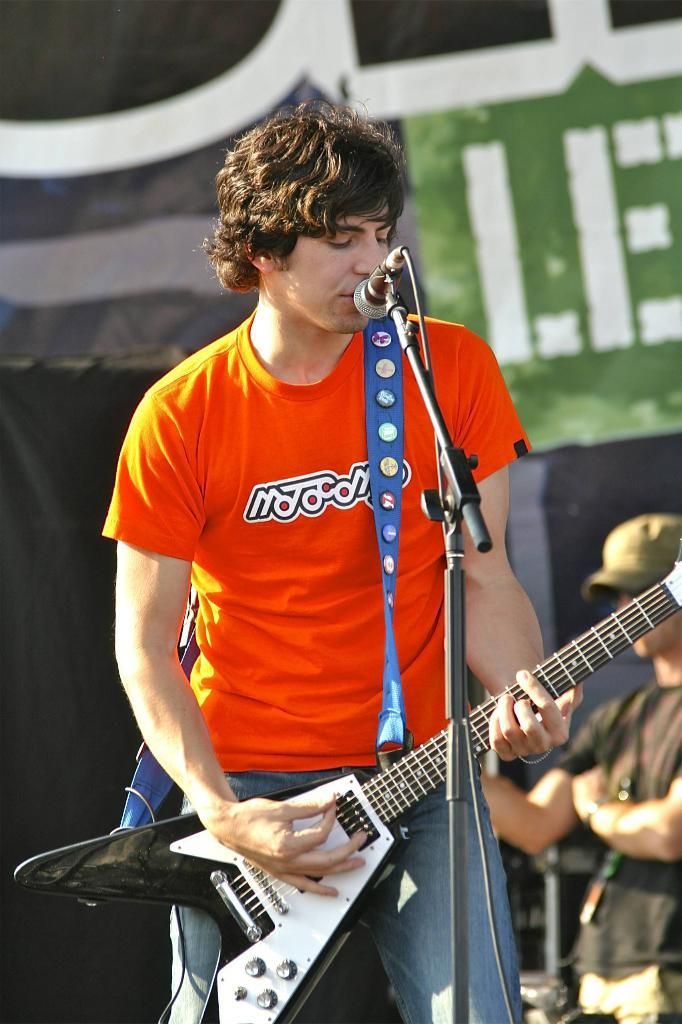What is the man in the image doing? The man in the image is playing a guitar. How is the guitar being held by the man? The man is holding the guitar in his hand. What is in front of the man while he is playing the guitar? There is a microphone in front of the man. Is there anyone else in the image besides the man playing the guitar? Yes, there is another man standing behind the first man. What type of suit is the man wearing while skating in the image? There is no man skating in the image, and no one is wearing a suit. 